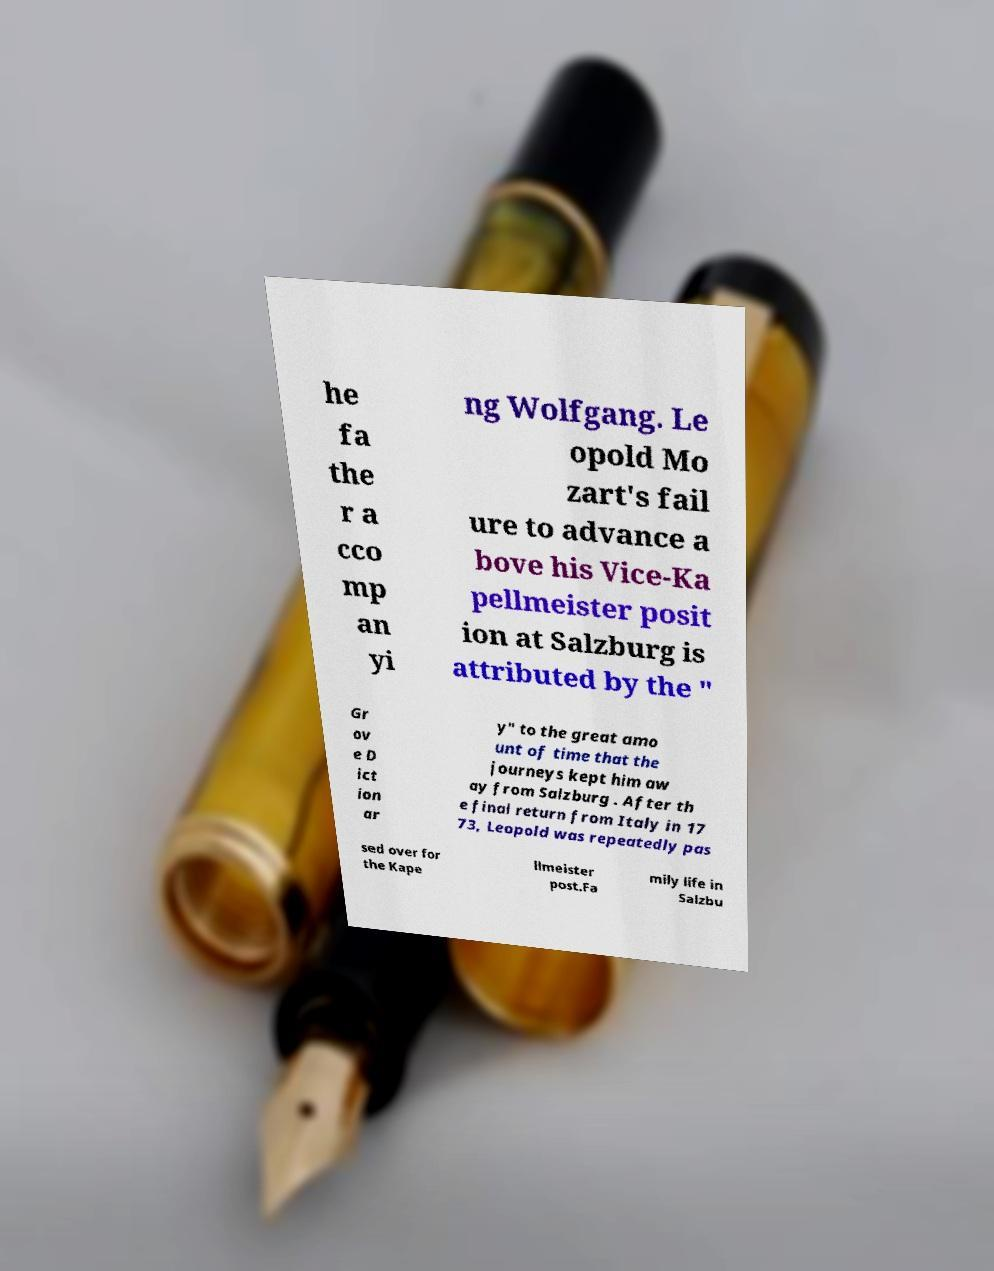Please read and relay the text visible in this image. What does it say? he fa the r a cco mp an yi ng Wolfgang. Le opold Mo zart's fail ure to advance a bove his Vice-Ka pellmeister posit ion at Salzburg is attributed by the " Gr ov e D ict ion ar y" to the great amo unt of time that the journeys kept him aw ay from Salzburg . After th e final return from Italy in 17 73, Leopold was repeatedly pas sed over for the Kape llmeister post.Fa mily life in Salzbu 